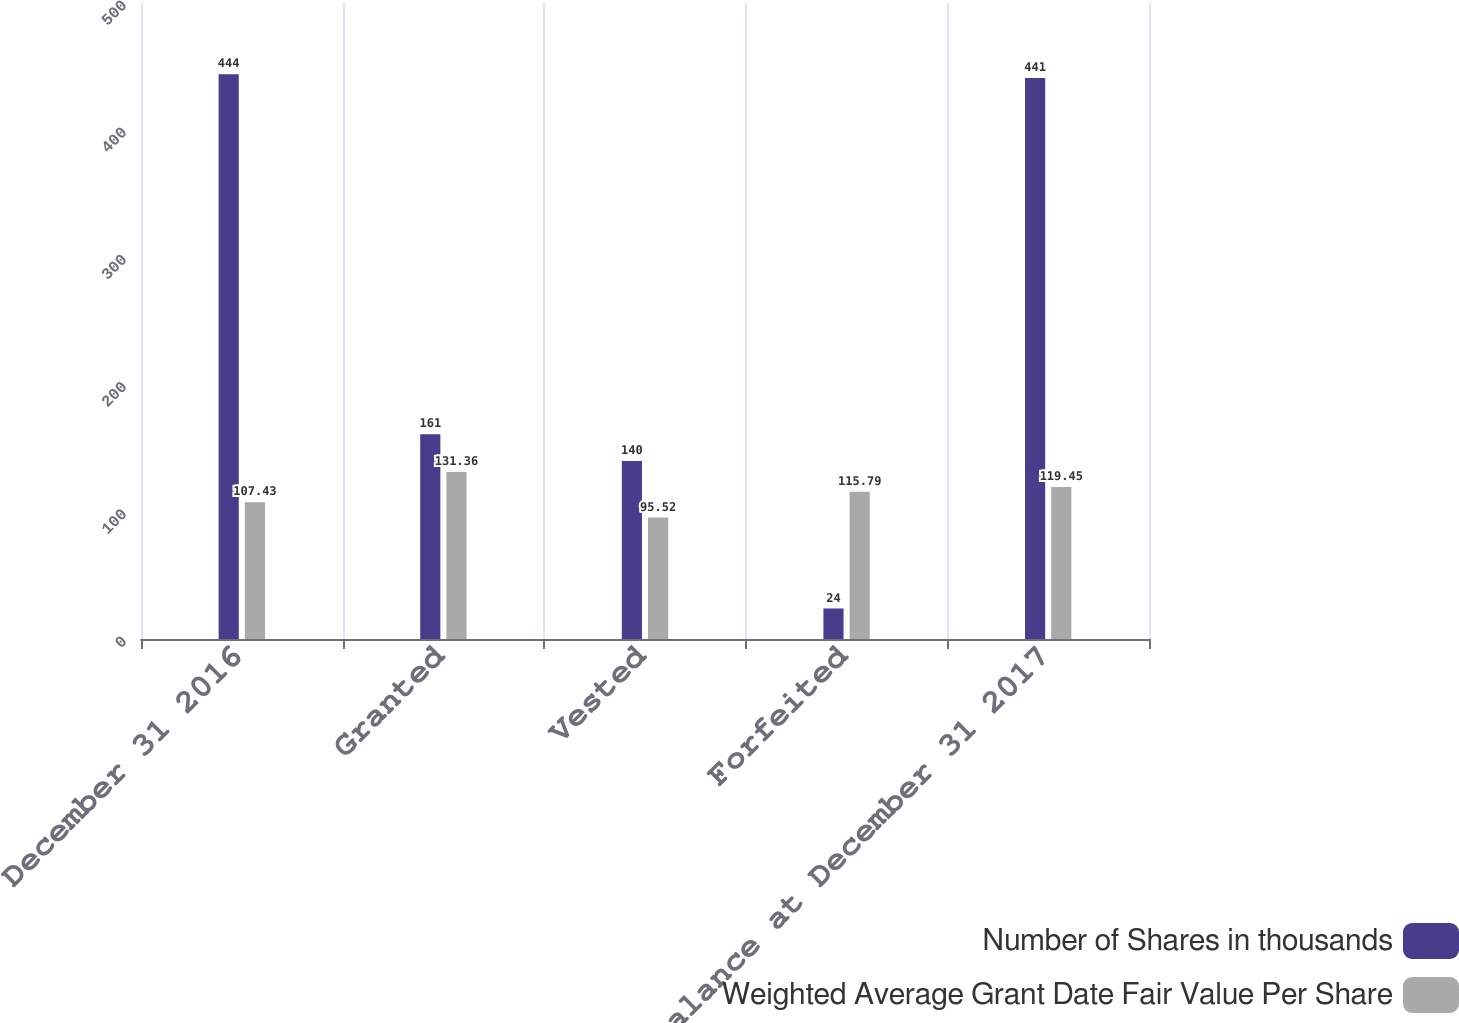<chart> <loc_0><loc_0><loc_500><loc_500><stacked_bar_chart><ecel><fcel>December 31 2016<fcel>Granted<fcel>Vested<fcel>Forfeited<fcel>Balance at December 31 2017<nl><fcel>Number of Shares in thousands<fcel>444<fcel>161<fcel>140<fcel>24<fcel>441<nl><fcel>Weighted Average Grant Date Fair Value Per Share<fcel>107.43<fcel>131.36<fcel>95.52<fcel>115.79<fcel>119.45<nl></chart> 